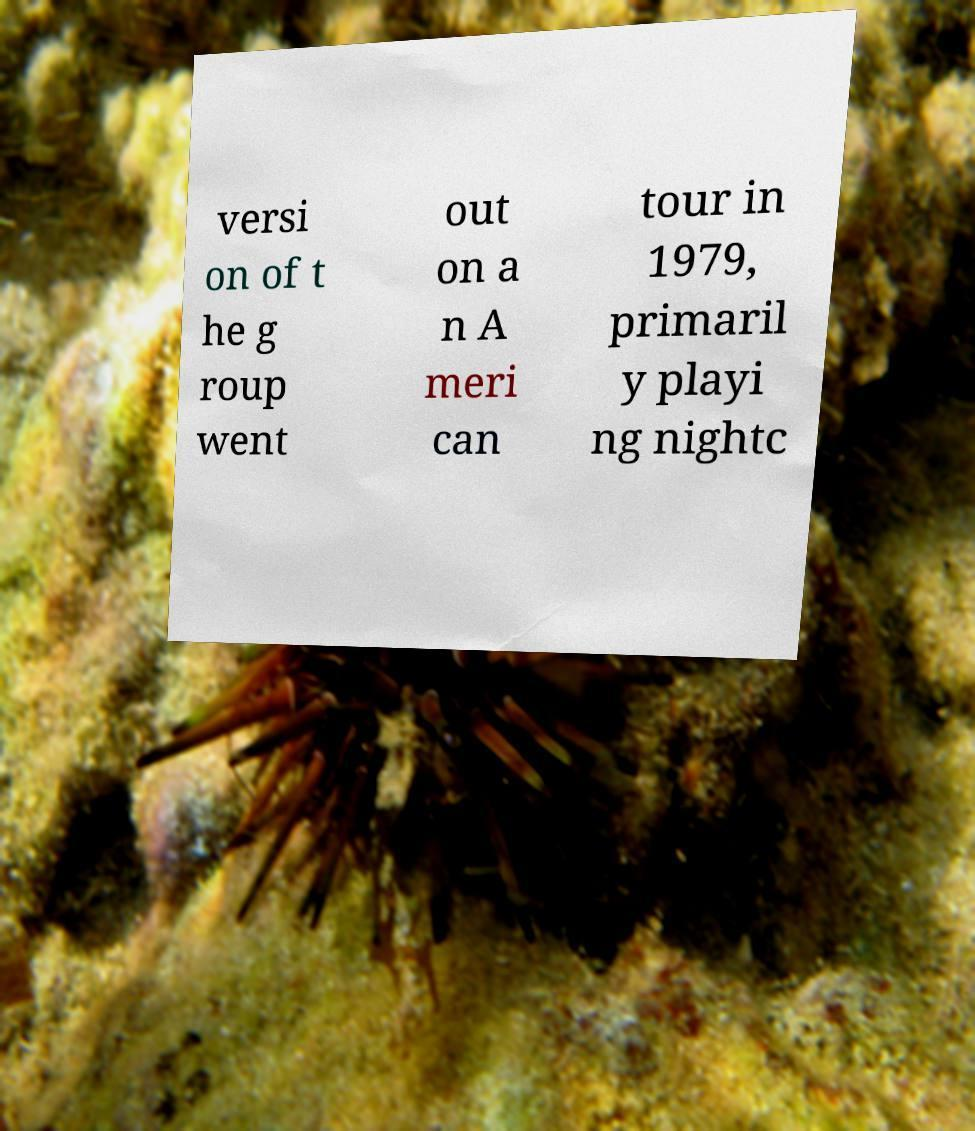There's text embedded in this image that I need extracted. Can you transcribe it verbatim? versi on of t he g roup went out on a n A meri can tour in 1979, primaril y playi ng nightc 